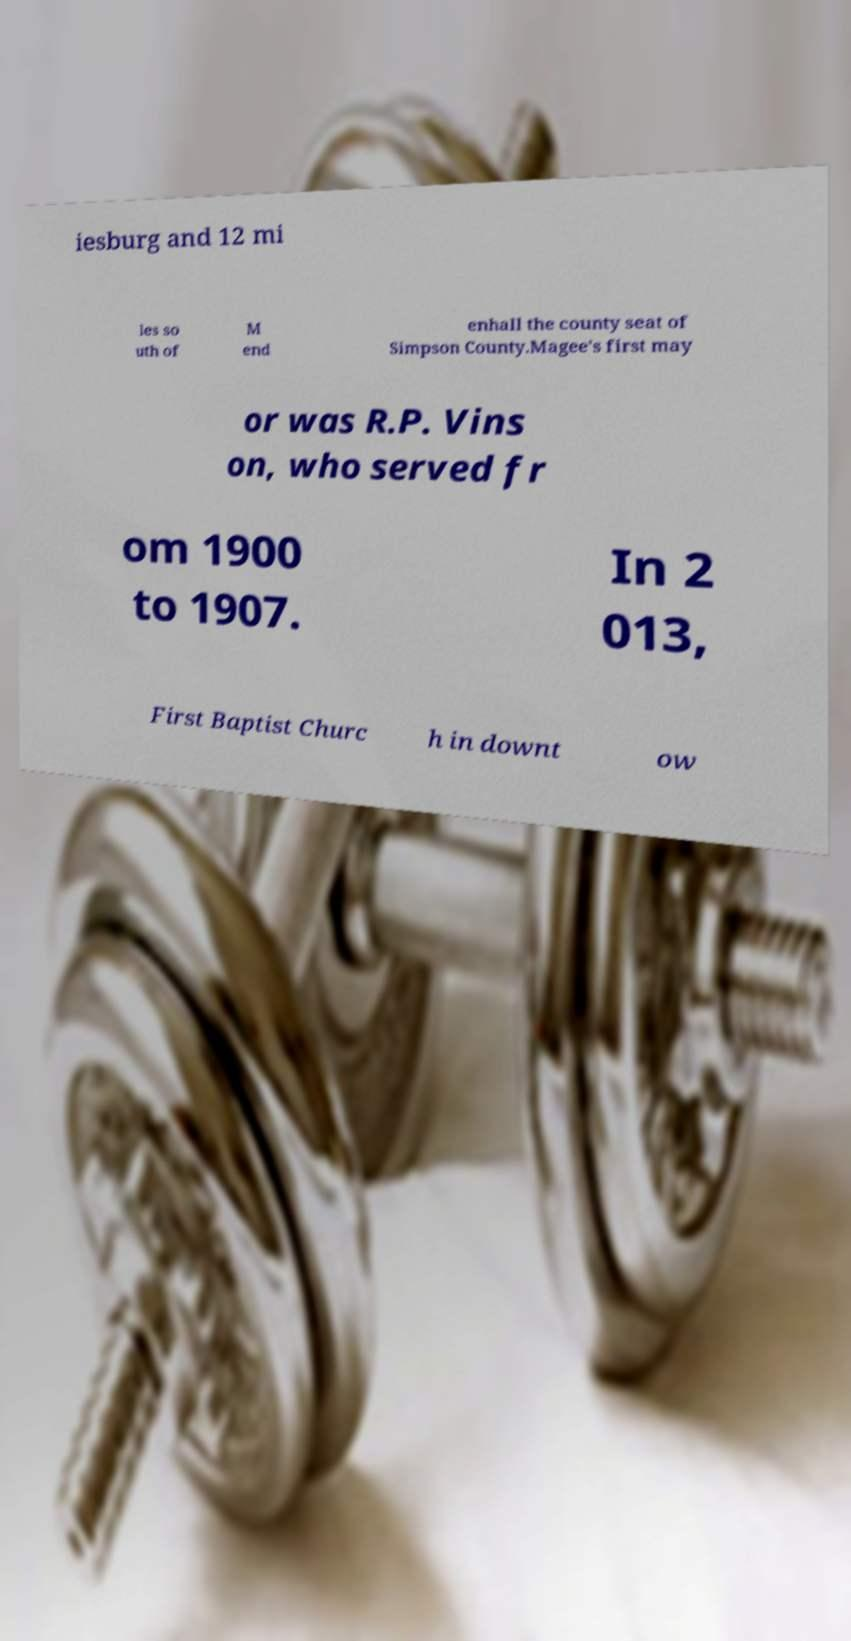What messages or text are displayed in this image? I need them in a readable, typed format. iesburg and 12 mi les so uth of M end enhall the county seat of Simpson County.Magee's first may or was R.P. Vins on, who served fr om 1900 to 1907. In 2 013, First Baptist Churc h in downt ow 